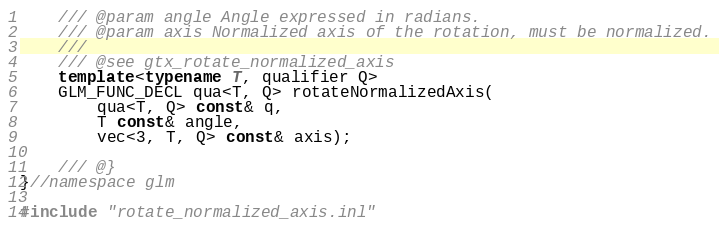<code> <loc_0><loc_0><loc_500><loc_500><_C++_>	/// @param angle Angle expressed in radians.
	/// @param axis Normalized axis of the rotation, must be normalized.
	///
	/// @see gtx_rotate_normalized_axis
	template<typename T, qualifier Q>
	GLM_FUNC_DECL qua<T, Q> rotateNormalizedAxis(
		qua<T, Q> const& q,
		T const& angle,
		vec<3, T, Q> const& axis);

	/// @}
}//namespace glm

#include "rotate_normalized_axis.inl"
</code> 